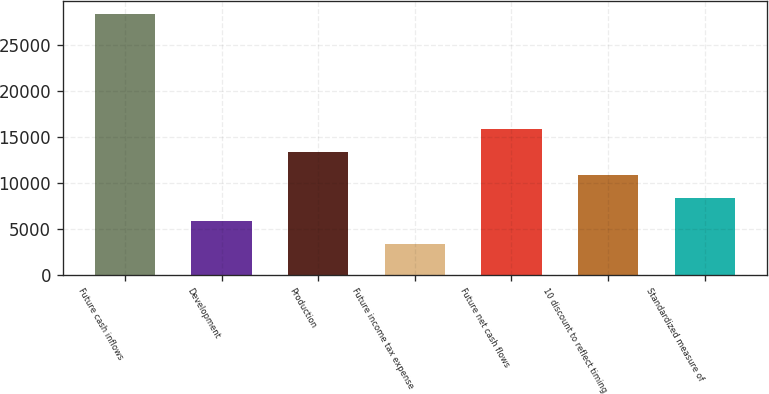<chart> <loc_0><loc_0><loc_500><loc_500><bar_chart><fcel>Future cash inflows<fcel>Development<fcel>Production<fcel>Future income tax expense<fcel>Future net cash flows<fcel>10 discount to reflect timing<fcel>Standardized measure of<nl><fcel>28442<fcel>5911.4<fcel>13421.6<fcel>3408<fcel>15925<fcel>10918.2<fcel>8414.8<nl></chart> 